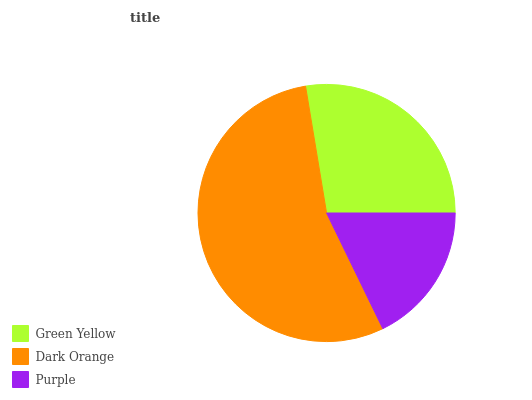Is Purple the minimum?
Answer yes or no. Yes. Is Dark Orange the maximum?
Answer yes or no. Yes. Is Dark Orange the minimum?
Answer yes or no. No. Is Purple the maximum?
Answer yes or no. No. Is Dark Orange greater than Purple?
Answer yes or no. Yes. Is Purple less than Dark Orange?
Answer yes or no. Yes. Is Purple greater than Dark Orange?
Answer yes or no. No. Is Dark Orange less than Purple?
Answer yes or no. No. Is Green Yellow the high median?
Answer yes or no. Yes. Is Green Yellow the low median?
Answer yes or no. Yes. Is Dark Orange the high median?
Answer yes or no. No. Is Dark Orange the low median?
Answer yes or no. No. 